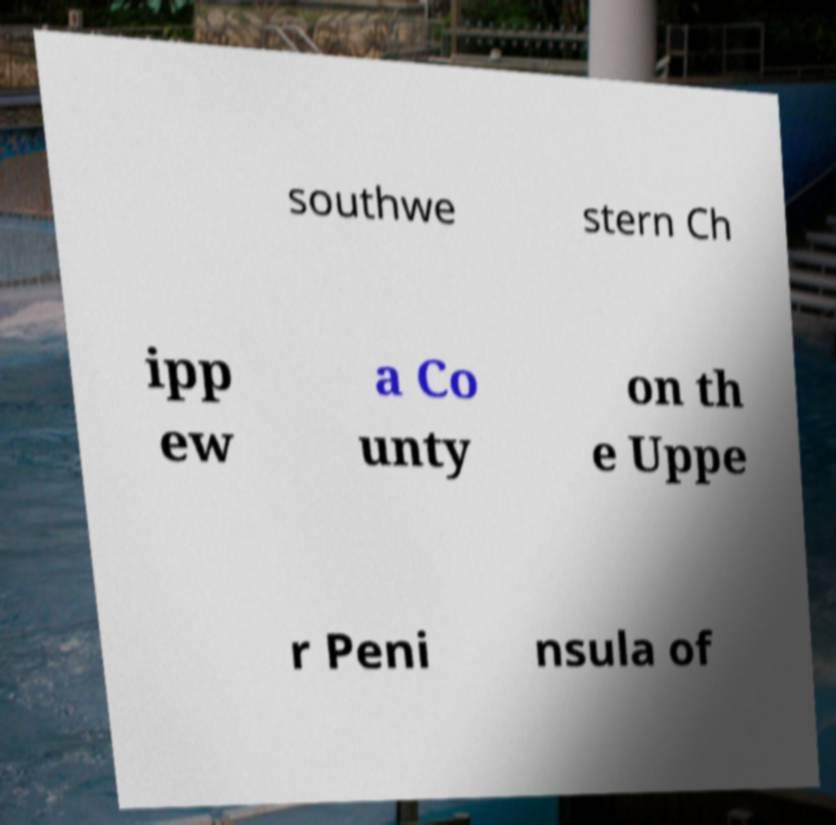For documentation purposes, I need the text within this image transcribed. Could you provide that? southwe stern Ch ipp ew a Co unty on th e Uppe r Peni nsula of 